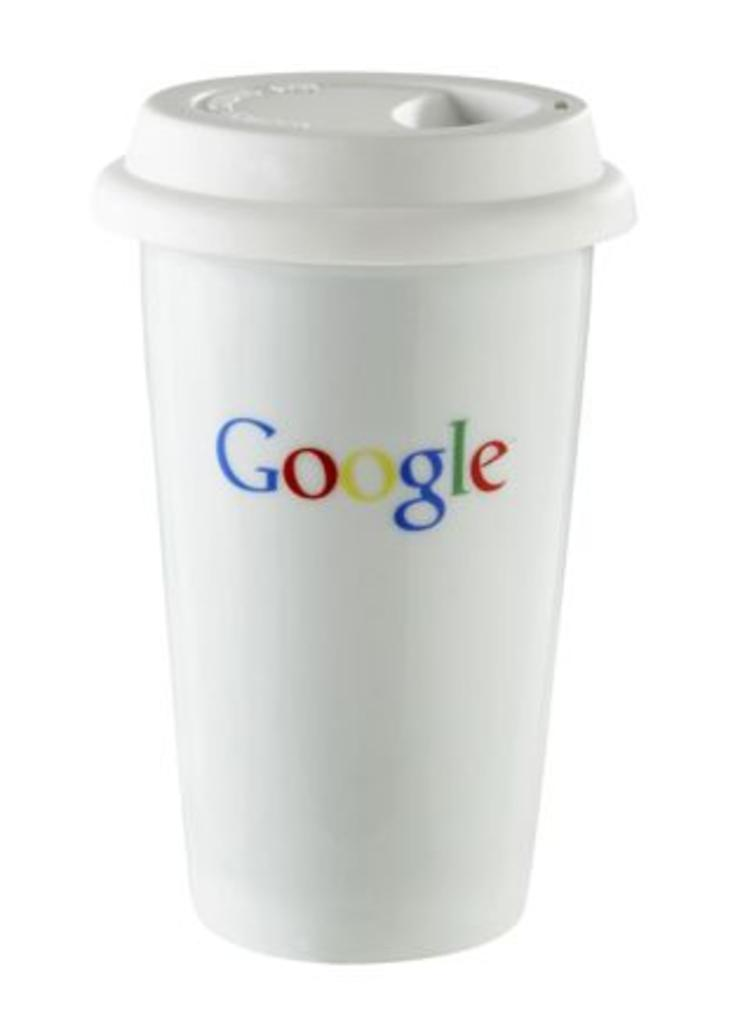<image>
Describe the image concisely. A resusable coffee cup bears the Google logo. 